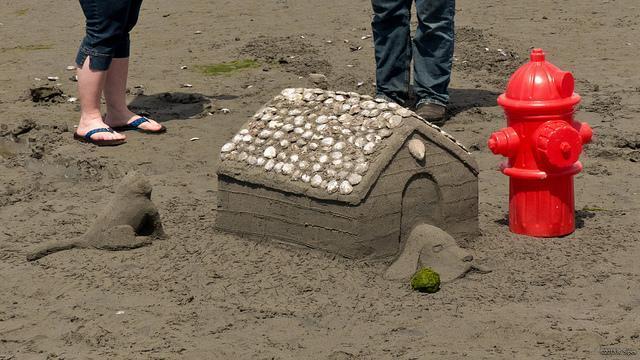How many people are there?
Give a very brief answer. 2. How many cars are covered in snow?
Give a very brief answer. 0. 